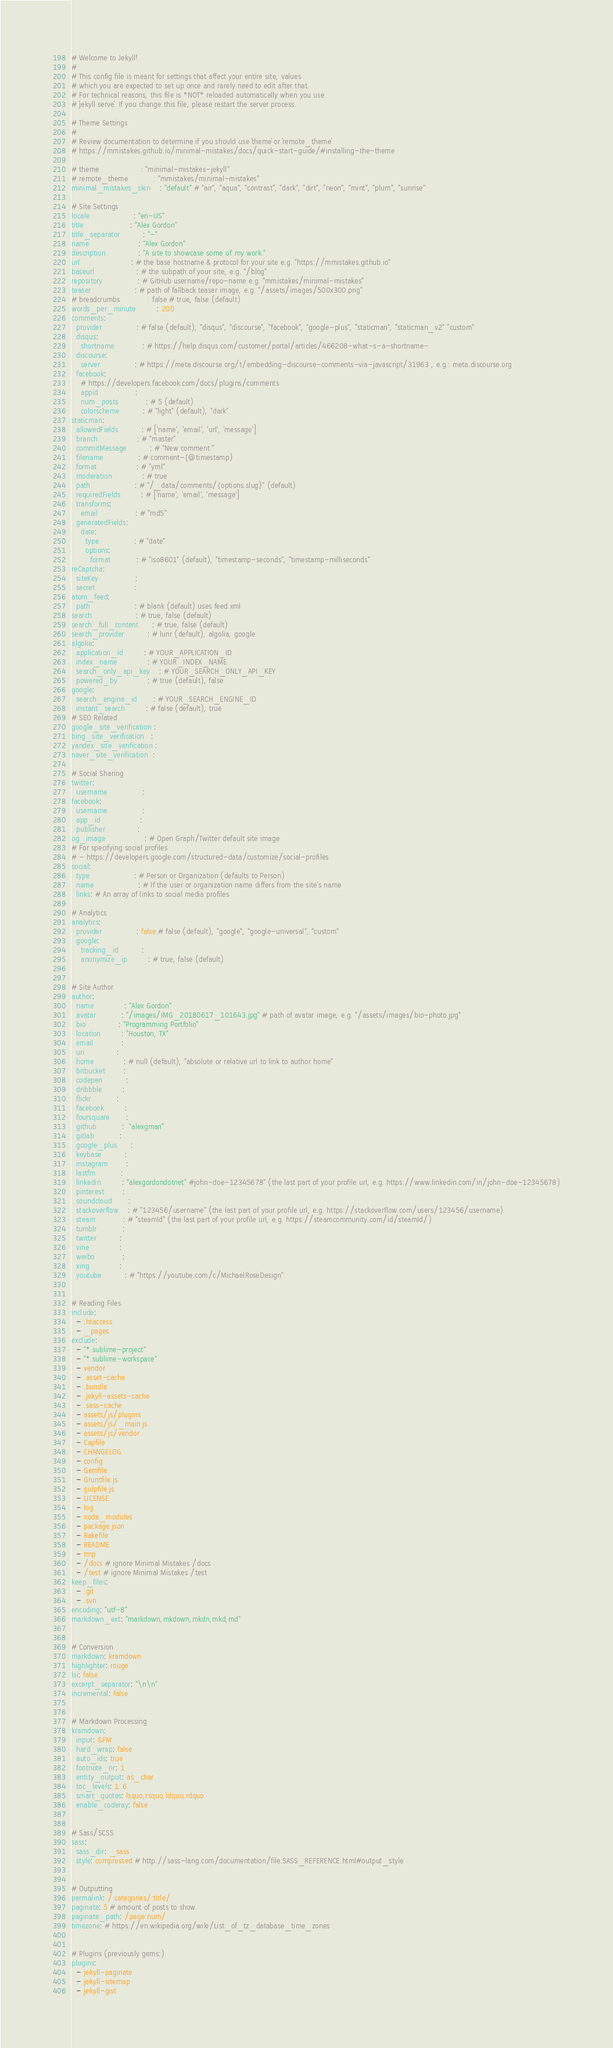Convert code to text. <code><loc_0><loc_0><loc_500><loc_500><_YAML_># Welcome to Jekyll!
#
# This config file is meant for settings that affect your entire site, values
# which you are expected to set up once and rarely need to edit after that.
# For technical reasons, this file is *NOT* reloaded automatically when you use
# `jekyll serve`. If you change this file, please restart the server process.

# Theme Settings
#
# Review documentation to determine if you should use `theme` or `remote_theme`
# https://mmistakes.github.io/minimal-mistakes/docs/quick-start-guide/#installing-the-theme

# theme                  : "minimal-mistakes-jekyll"
# remote_theme           : "mmistakes/minimal-mistakes"
minimal_mistakes_skin    : "default" # "air", "aqua", "contrast", "dark", "dirt", "neon", "mint", "plum", "sunrise"

# Site Settings
locale                   : "en-US"
title                    : "Alex Gordon"
title_separator          : "-"
name                     : "Alex Gordon"
description              : "A site to showcase some of my work."
url                      : # the base hostname & protocol for your site e.g. "https://mmistakes.github.io"
baseurl                  : # the subpath of your site, e.g. "/blog"
repository               : # GitHub username/repo-name e.g. "mmistakes/minimal-mistakes"
teaser                   : # path of fallback teaser image, e.g. "/assets/images/500x300.png"
# breadcrumbs            : false # true, false (default)
words_per_minute         : 200
comments:
  provider               : # false (default), "disqus", "discourse", "facebook", "google-plus", "staticman", "staticman_v2" "custom"
  disqus:
    shortname            : # https://help.disqus.com/customer/portal/articles/466208-what-s-a-shortname-
  discourse:
    server               : # https://meta.discourse.org/t/embedding-discourse-comments-via-javascript/31963 , e.g.: meta.discourse.org
  facebook:
    # https://developers.facebook.com/docs/plugins/comments
    appid                :
    num_posts            : # 5 (default)
    colorscheme          : # "light" (default), "dark"
staticman:
  allowedFields          : # ['name', 'email', 'url', 'message']
  branch                 : # "master"
  commitMessage          : # "New comment."
  filename               : # comment-{@timestamp}
  format                 : # "yml"
  moderation             : # true
  path                   : # "/_data/comments/{options.slug}" (default)
  requiredFields         : # ['name', 'email', 'message']
  transforms:
    email                : # "md5"
  generatedFields:
    date:
      type               : # "date"
      options:
        format           : # "iso8601" (default), "timestamp-seconds", "timestamp-milliseconds"
reCaptcha:
  siteKey                :
  secret                 :
atom_feed:
  path                   : # blank (default) uses feed.xml
search                   : # true, false (default)
search_full_content      : # true, false (default)
search_provider          : # lunr (default), algolia, google
algolia:
  application_id         : # YOUR_APPLICATION_ID
  index_name             : # YOUR_INDEX_NAME
  search_only_api_key    : # YOUR_SEARCH_ONLY_API_KEY
  powered_by             : # true (default), false
google:
  search_engine_id       : # YOUR_SEARCH_ENGINE_ID
  instant_search         : # false (default), true
# SEO Related
google_site_verification :
bing_site_verification   :
yandex_site_verification :
naver_site_verification  :

# Social Sharing
twitter:
  username               :
facebook:
  username               :
  app_id                 :
  publisher              :
og_image                 : # Open Graph/Twitter default site image
# For specifying social profiles
# - https://developers.google.com/structured-data/customize/social-profiles
social:
  type                   : # Person or Organization (defaults to Person)
  name                   : # If the user or organization name differs from the site's name
  links: # An array of links to social media profiles

# Analytics
analytics:
  provider               : false # false (default), "google", "google-universal", "custom"
  google:
    tracking_id          :
    anonymize_ip         : # true, false (default)


# Site Author
author:
  name             : "Alex Gordon"
  avatar           : "/images/IMG_20180617_101643.jpg" # path of avatar image, e.g. "/assets/images/bio-photo.jpg"
  bio              : "Programming Portfolio"
  location         : "Houston, TX"
  email            :
  uri              :
  home             : # null (default), "absolute or relative url to link to author home"
  bitbucket        :
  codepen          :
  dribbble         :
  flickr           :
  facebook         :
  foursquare       :
  github           :  "alexgman"
  gitlab           :
  google_plus      :
  keybase          :
  instagram        :
  lastfm           :
  linkedin         : "alexgordondotnet" #john-doe-12345678" (the last part of your profile url, e.g. https://www.linkedin.com/in/john-doe-12345678)
  pinterest        :
  soundcloud       :
  stackoverflow    : # "123456/username" (the last part of your profile url, e.g. https://stackoverflow.com/users/123456/username)
  steam            : # "steamId" (the last part of your profile url, e.g. https://steamcommunity.com/id/steamId/)
  tumblr           :
  twitter          :
  vine             :
  weibo            :
  xing             :
  youtube          : # "https://youtube.com/c/MichaelRoseDesign"


# Reading Files
include:
  - .htaccess
  - _pages
exclude:
  - "*.sublime-project"
  - "*.sublime-workspace"
  - vendor
  - .asset-cache
  - .bundle
  - .jekyll-assets-cache
  - .sass-cache
  - assets/js/plugins
  - assets/js/_main.js
  - assets/js/vendor
  - Capfile
  - CHANGELOG
  - config
  - Gemfile
  - Gruntfile.js
  - gulpfile.js
  - LICENSE
  - log
  - node_modules
  - package.json
  - Rakefile
  - README
  - tmp
  - /docs # ignore Minimal Mistakes /docs
  - /test # ignore Minimal Mistakes /test
keep_files:
  - .git
  - .svn
encoding: "utf-8"
markdown_ext: "markdown,mkdown,mkdn,mkd,md"


# Conversion
markdown: kramdown
highlighter: rouge
lsi: false
excerpt_separator: "\n\n"
incremental: false


# Markdown Processing
kramdown:
  input: GFM
  hard_wrap: false
  auto_ids: true
  footnote_nr: 1
  entity_output: as_char
  toc_levels: 1..6
  smart_quotes: lsquo,rsquo,ldquo,rdquo
  enable_coderay: false


# Sass/SCSS
sass:
  sass_dir: _sass
  style: compressed # http://sass-lang.com/documentation/file.SASS_REFERENCE.html#output_style


# Outputting
permalink: /:categories/:title/
paginate: 5 # amount of posts to show
paginate_path: /page:num/
timezone: # https://en.wikipedia.org/wiki/List_of_tz_database_time_zones


# Plugins (previously gems:)
plugins:
  - jekyll-paginate
  - jekyll-sitemap
  - jekyll-gist</code> 